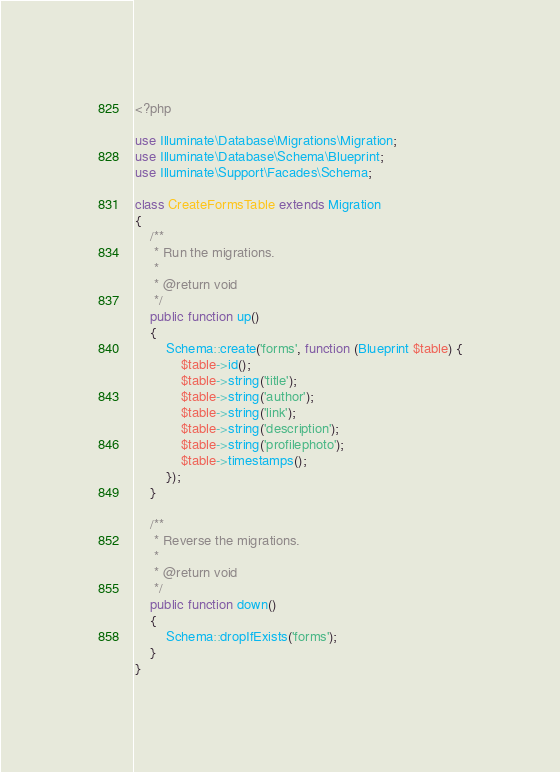<code> <loc_0><loc_0><loc_500><loc_500><_PHP_><?php

use Illuminate\Database\Migrations\Migration;
use Illuminate\Database\Schema\Blueprint;
use Illuminate\Support\Facades\Schema;

class CreateFormsTable extends Migration
{
    /**
     * Run the migrations.
     *
     * @return void
     */
    public function up()
    {
        Schema::create('forms', function (Blueprint $table) {
            $table->id();
            $table->string('title');
            $table->string('author');
            $table->string('link');
            $table->string('description');
            $table->string('profilephoto');
            $table->timestamps();
        });
    }

    /**
     * Reverse the migrations.
     *
     * @return void
     */
    public function down()
    {
        Schema::dropIfExists('forms');
    }
}
</code> 